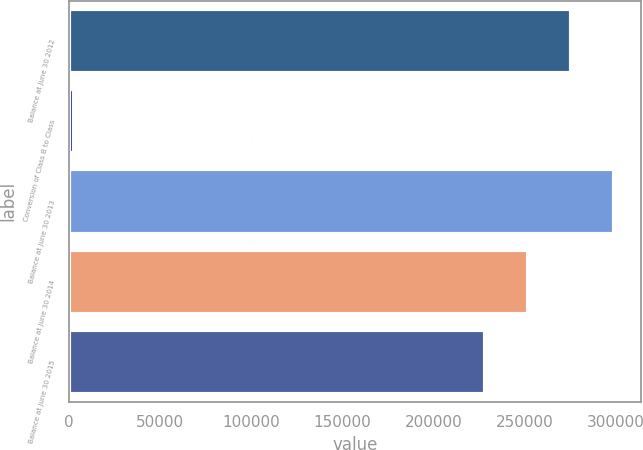Convert chart. <chart><loc_0><loc_0><loc_500><loc_500><bar_chart><fcel>Balance at June 30 2012<fcel>Conversion of Class B to Class<fcel>Balance at June 30 2013<fcel>Balance at June 30 2014<fcel>Balance at June 30 2015<nl><fcel>275079<fcel>2800<fcel>298701<fcel>251458<fcel>227836<nl></chart> 